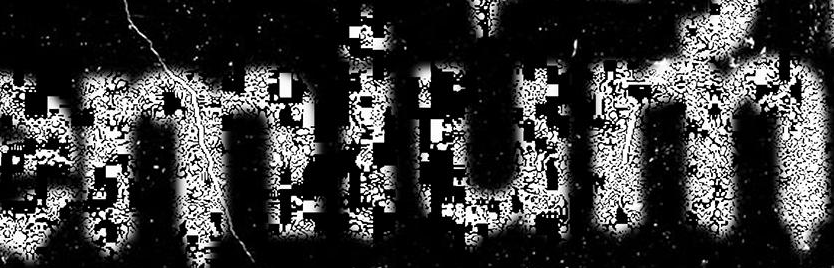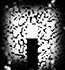Read the text content from these images in order, separated by a semicolon. emium; . 